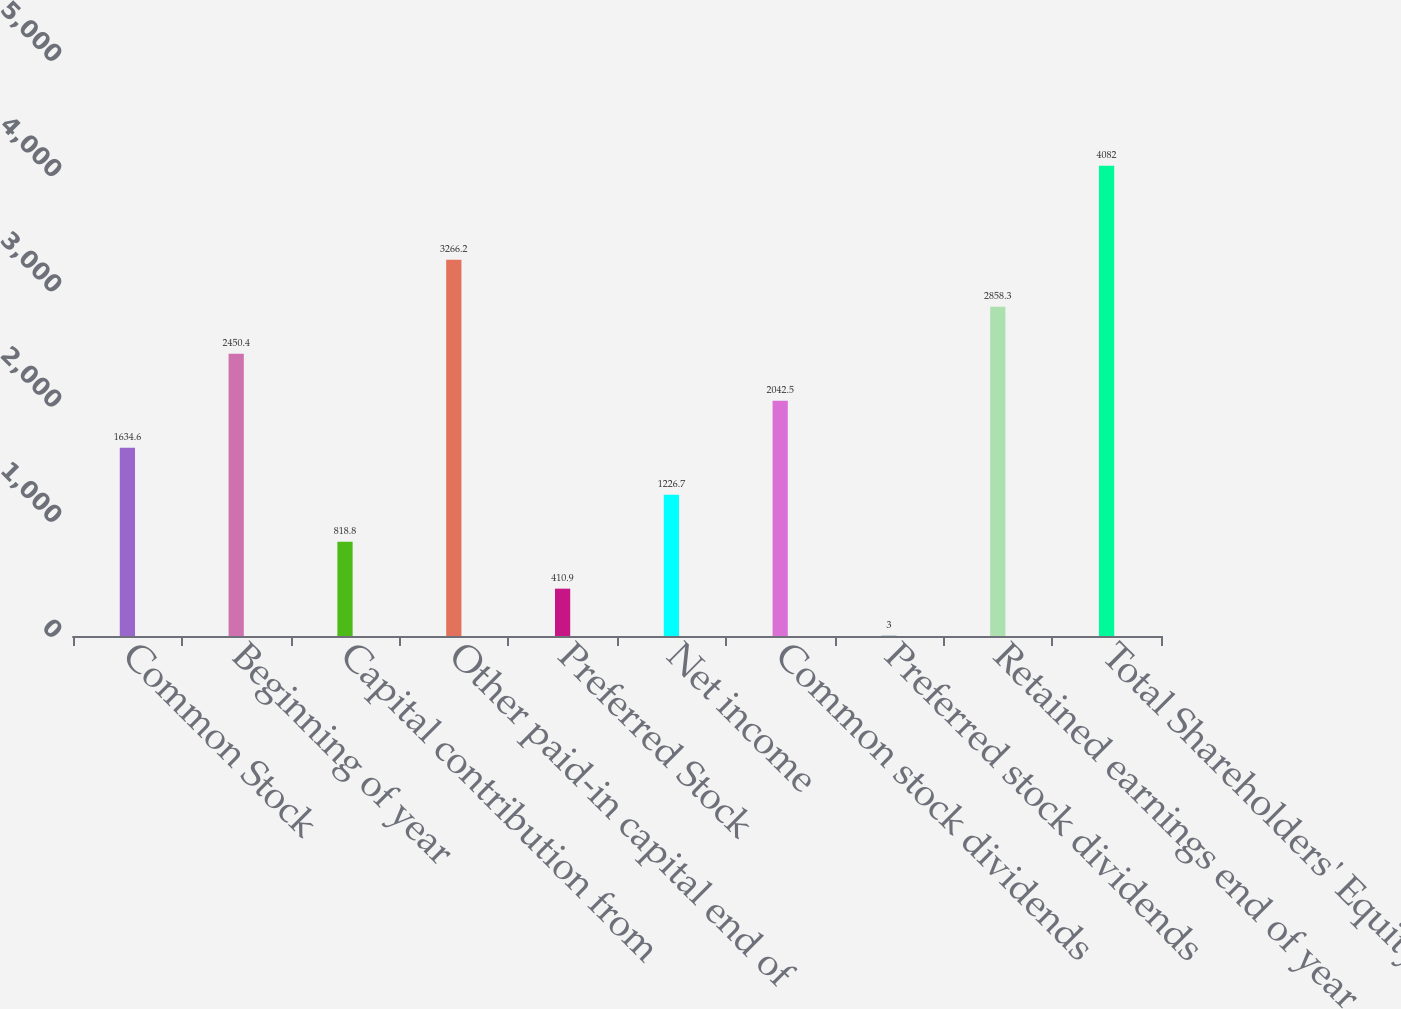Convert chart to OTSL. <chart><loc_0><loc_0><loc_500><loc_500><bar_chart><fcel>Common Stock<fcel>Beginning of year<fcel>Capital contribution from<fcel>Other paid-in capital end of<fcel>Preferred Stock<fcel>Net income<fcel>Common stock dividends<fcel>Preferred stock dividends<fcel>Retained earnings end of year<fcel>Total Shareholders' Equity<nl><fcel>1634.6<fcel>2450.4<fcel>818.8<fcel>3266.2<fcel>410.9<fcel>1226.7<fcel>2042.5<fcel>3<fcel>2858.3<fcel>4082<nl></chart> 